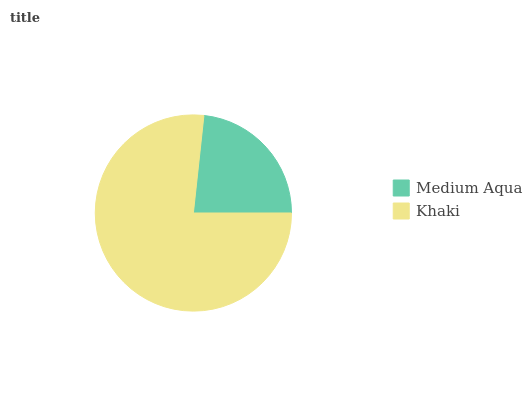Is Medium Aqua the minimum?
Answer yes or no. Yes. Is Khaki the maximum?
Answer yes or no. Yes. Is Khaki the minimum?
Answer yes or no. No. Is Khaki greater than Medium Aqua?
Answer yes or no. Yes. Is Medium Aqua less than Khaki?
Answer yes or no. Yes. Is Medium Aqua greater than Khaki?
Answer yes or no. No. Is Khaki less than Medium Aqua?
Answer yes or no. No. Is Khaki the high median?
Answer yes or no. Yes. Is Medium Aqua the low median?
Answer yes or no. Yes. Is Medium Aqua the high median?
Answer yes or no. No. Is Khaki the low median?
Answer yes or no. No. 